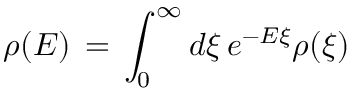<formula> <loc_0><loc_0><loc_500><loc_500>\rho ( E ) \, = \, \int _ { 0 } ^ { \infty } d \xi \, e ^ { - E \xi } \rho ( \xi )</formula> 